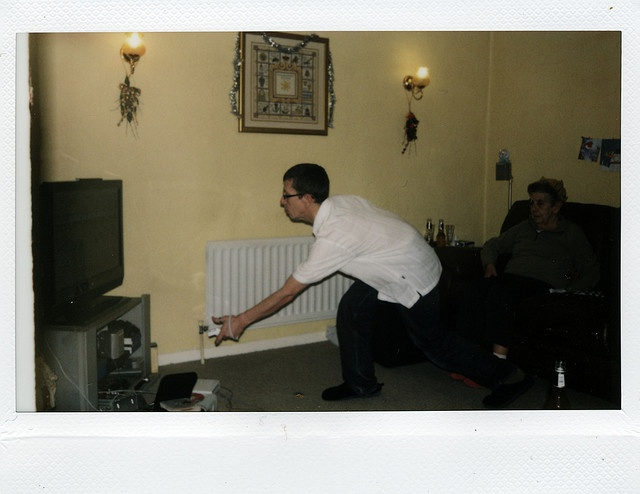Describe the objects in this image and their specific colors. I can see people in white, black, darkgray, gray, and brown tones, people in white, black, darkgreen, and gray tones, tv in white, black, gray, darkgreen, and olive tones, couch in white and black tones, and bottle in white, black, darkgray, gray, and lightgray tones in this image. 